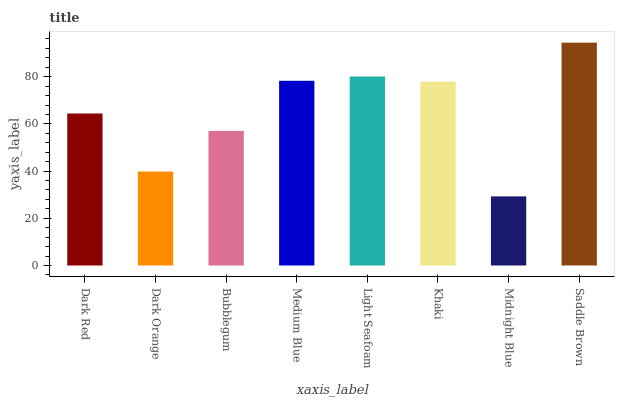Is Midnight Blue the minimum?
Answer yes or no. Yes. Is Saddle Brown the maximum?
Answer yes or no. Yes. Is Dark Orange the minimum?
Answer yes or no. No. Is Dark Orange the maximum?
Answer yes or no. No. Is Dark Red greater than Dark Orange?
Answer yes or no. Yes. Is Dark Orange less than Dark Red?
Answer yes or no. Yes. Is Dark Orange greater than Dark Red?
Answer yes or no. No. Is Dark Red less than Dark Orange?
Answer yes or no. No. Is Khaki the high median?
Answer yes or no. Yes. Is Dark Red the low median?
Answer yes or no. Yes. Is Dark Orange the high median?
Answer yes or no. No. Is Dark Orange the low median?
Answer yes or no. No. 